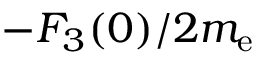Convert formula to latex. <formula><loc_0><loc_0><loc_500><loc_500>- F _ { 3 } ( 0 ) / 2 m _ { e }</formula> 